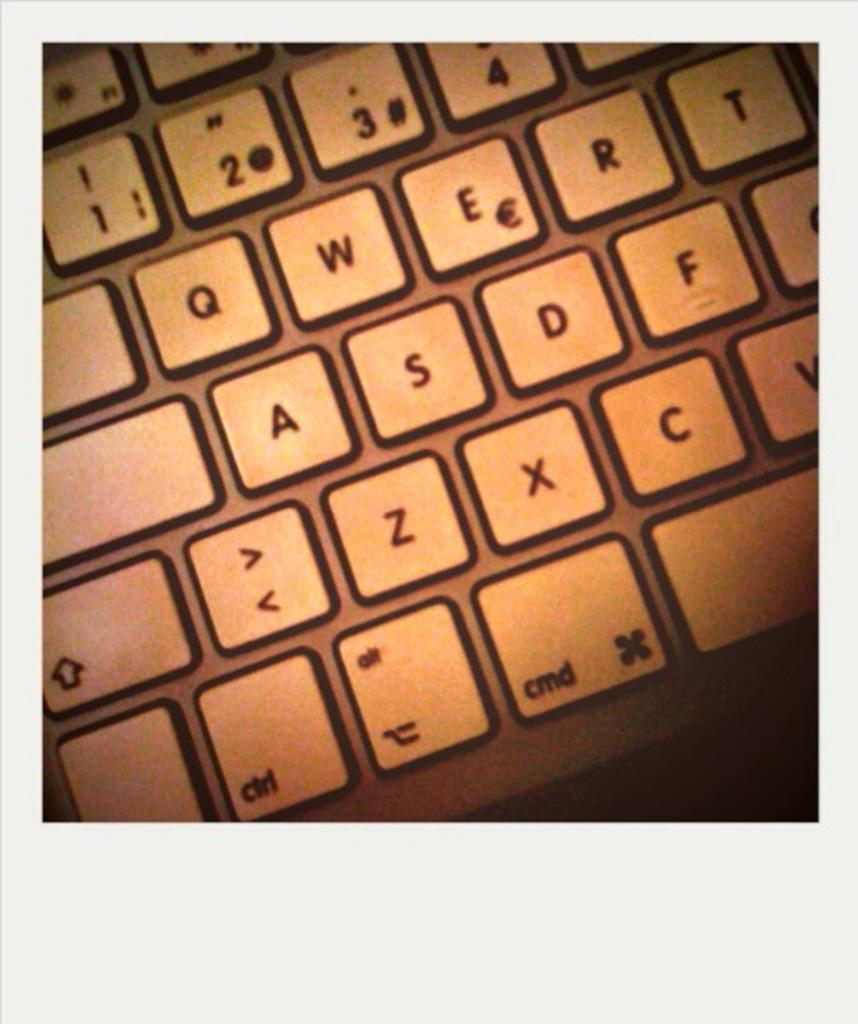<image>
Give a short and clear explanation of the subsequent image. A close up of a keyboard with the number one at the top left 